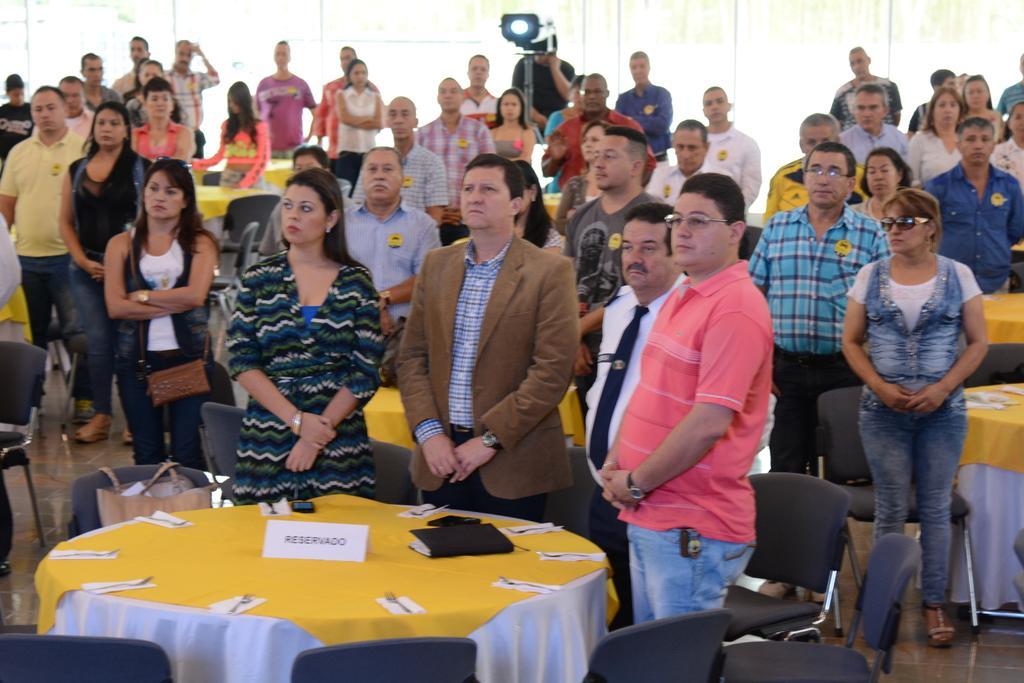Describe this image in one or two sentences. This image consists of so many tables and chairs. People are standing near the tables. On the tables there are books, spoons, tissues, boards. There is a projector machine on the top. 